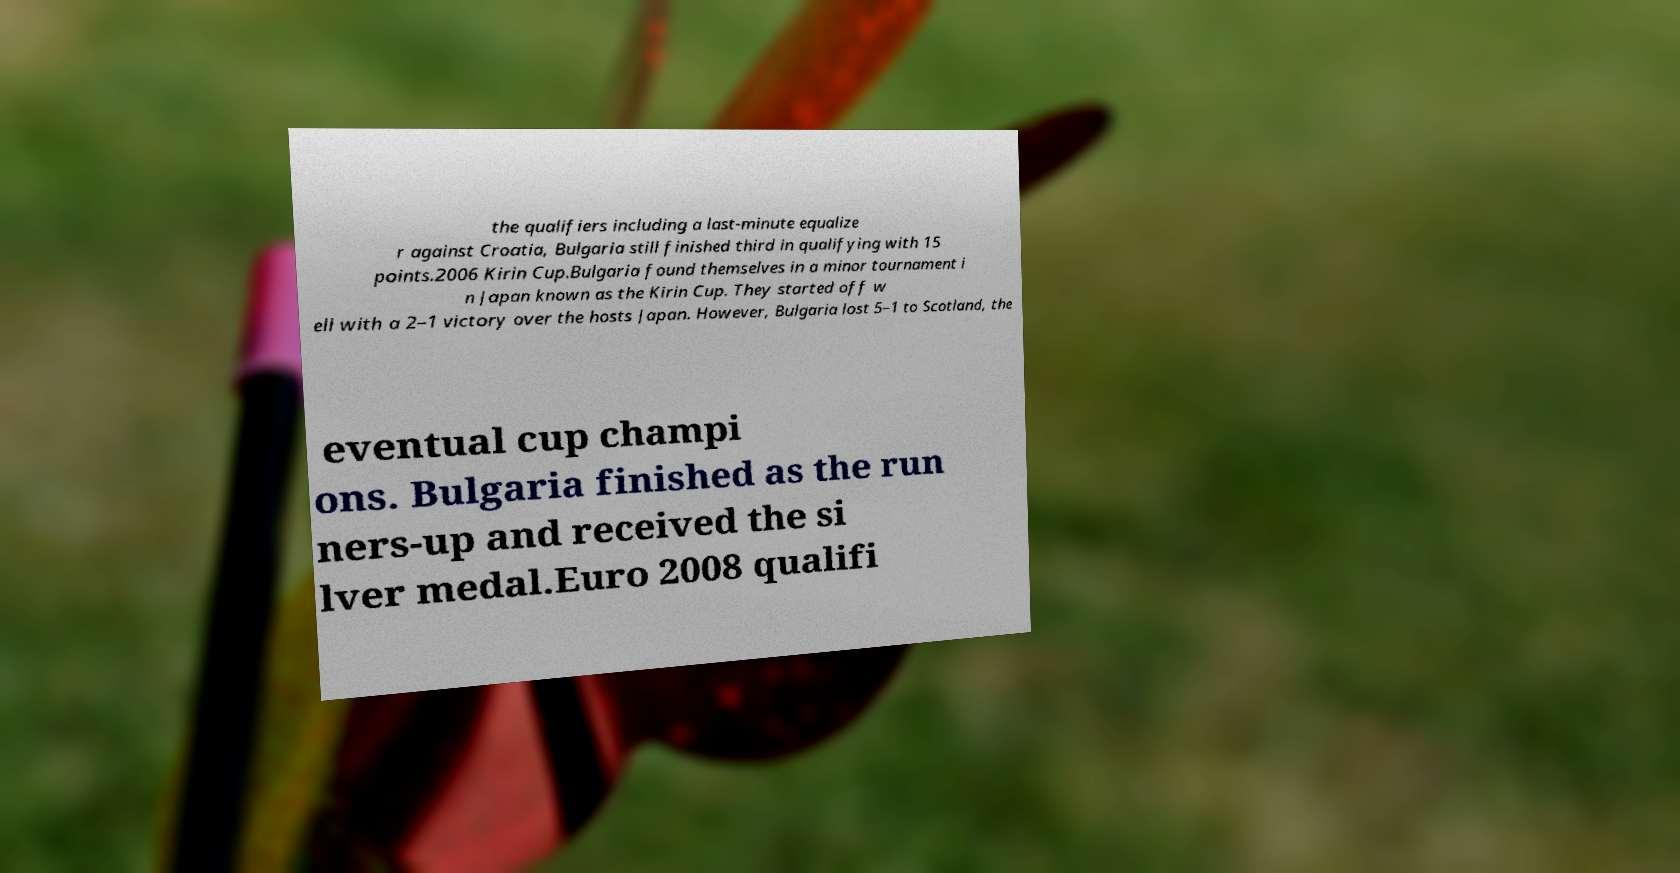Could you assist in decoding the text presented in this image and type it out clearly? the qualifiers including a last-minute equalize r against Croatia, Bulgaria still finished third in qualifying with 15 points.2006 Kirin Cup.Bulgaria found themselves in a minor tournament i n Japan known as the Kirin Cup. They started off w ell with a 2–1 victory over the hosts Japan. However, Bulgaria lost 5–1 to Scotland, the eventual cup champi ons. Bulgaria finished as the run ners-up and received the si lver medal.Euro 2008 qualifi 